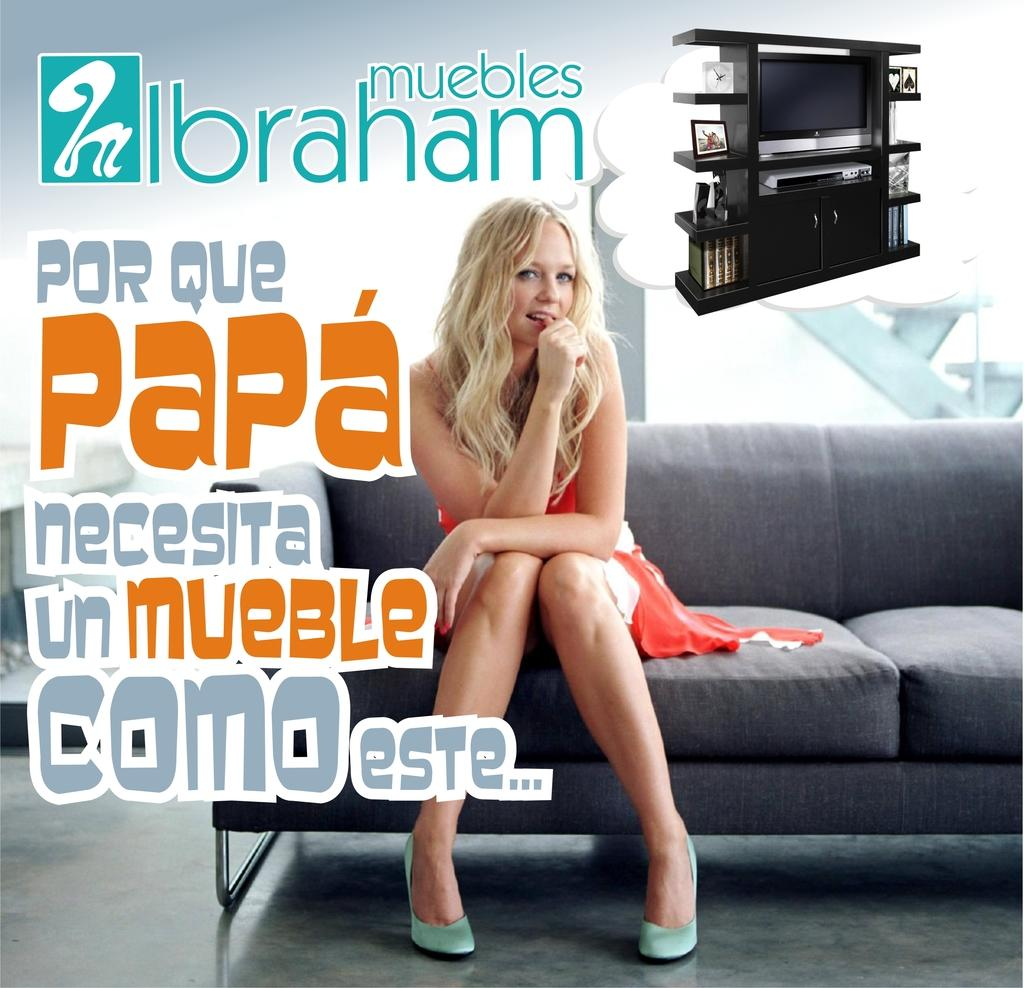<image>
Render a clear and concise summary of the photo. Orange text that says Papa is overlaid on a woman sitting on a couch. 